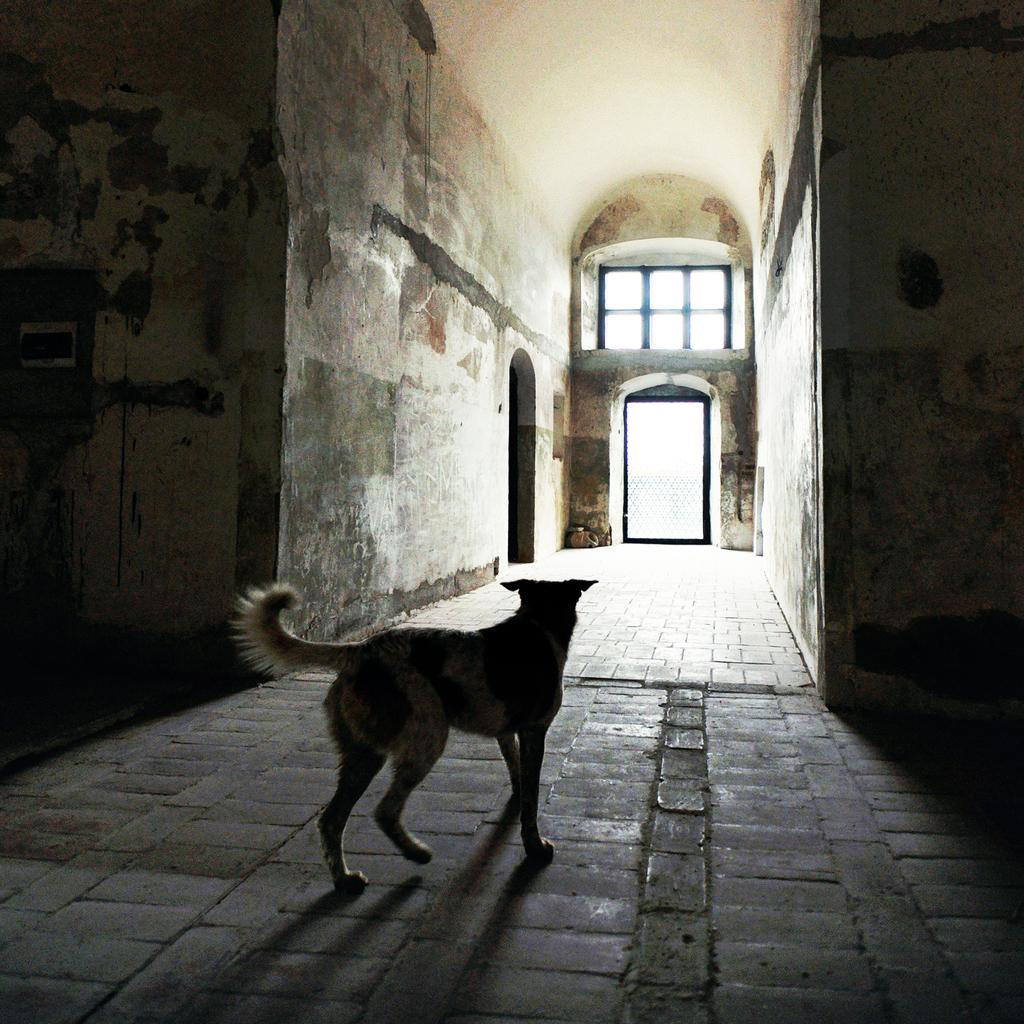What is the main subject in the foreground of the image? There is a dog in the foreground of the image. What is the dog doing in the image? The dog is on a path. What can be seen in the background of the image? There is a wall of a building and a ventilator in the background of the image. Are there any architectural features visible in the background? Yes, there are arches in the background of the image. What type of slave is depicted in the image? There is no depiction of a slave in the image; it features a dog on a path with a background containing a wall, a ventilator, and arches. 